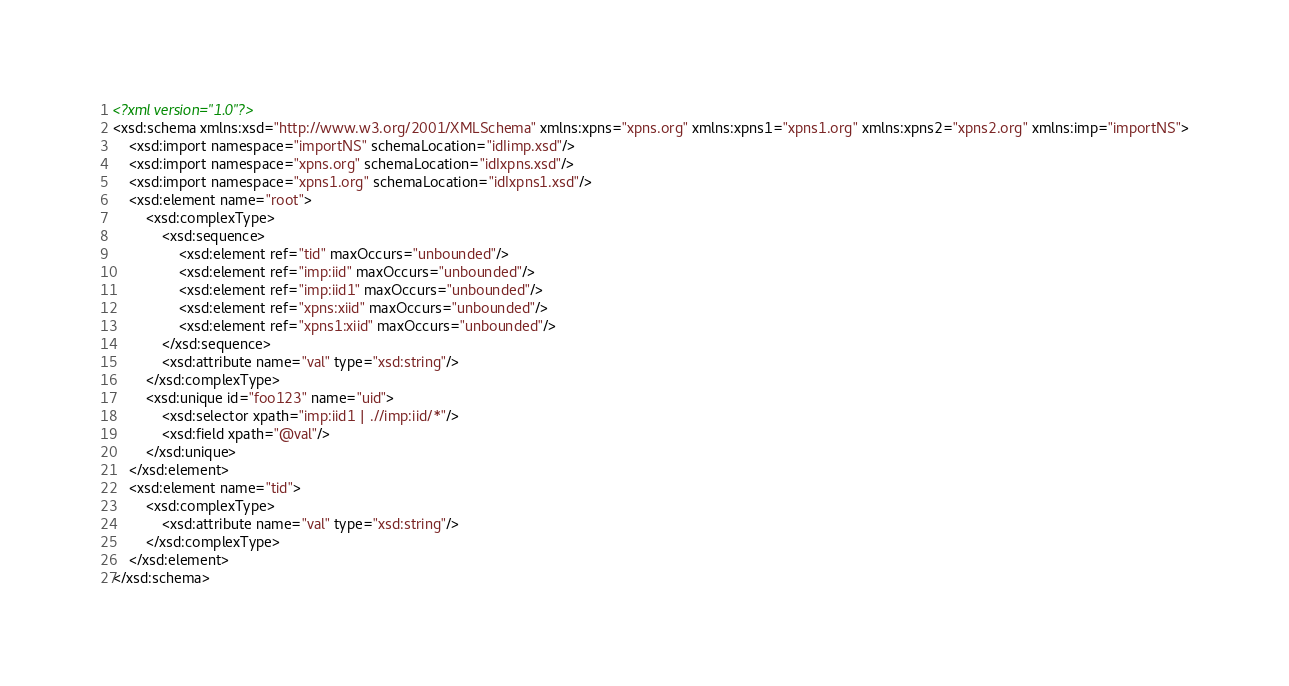Convert code to text. <code><loc_0><loc_0><loc_500><loc_500><_XML_><?xml version="1.0"?>
<xsd:schema xmlns:xsd="http://www.w3.org/2001/XMLSchema" xmlns:xpns="xpns.org" xmlns:xpns1="xpns1.org" xmlns:xpns2="xpns2.org" xmlns:imp="importNS">
	<xsd:import namespace="importNS" schemaLocation="idIimp.xsd"/>
	<xsd:import namespace="xpns.org" schemaLocation="idIxpns.xsd"/>
	<xsd:import namespace="xpns1.org" schemaLocation="idIxpns1.xsd"/>
	<xsd:element name="root">
		<xsd:complexType>
			<xsd:sequence>
				<xsd:element ref="tid" maxOccurs="unbounded"/>
				<xsd:element ref="imp:iid" maxOccurs="unbounded"/>
				<xsd:element ref="imp:iid1" maxOccurs="unbounded"/>
				<xsd:element ref="xpns:xiid" maxOccurs="unbounded"/>
				<xsd:element ref="xpns1:xiid" maxOccurs="unbounded"/>
			</xsd:sequence>
			<xsd:attribute name="val" type="xsd:string"/>
		</xsd:complexType>
		<xsd:unique id="foo123" name="uid">
			<xsd:selector xpath="imp:iid1 | .//imp:iid/*"/>
			<xsd:field xpath="@val"/>
		</xsd:unique>
	</xsd:element>
	<xsd:element name="tid">
		<xsd:complexType>
			<xsd:attribute name="val" type="xsd:string"/>
		</xsd:complexType>
	</xsd:element>
</xsd:schema>
</code> 